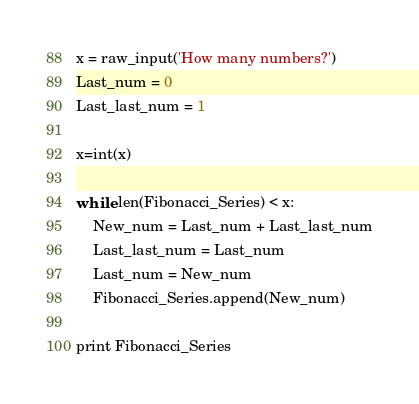<code> <loc_0><loc_0><loc_500><loc_500><_Python_>x = raw_input('How many numbers?')
Last_num = 0
Last_last_num = 1

x=int(x)

while len(Fibonacci_Series) < x:
    New_num = Last_num + Last_last_num
    Last_last_num = Last_num
    Last_num = New_num
    Fibonacci_Series.append(New_num)
    
print Fibonacci_Series
</code> 